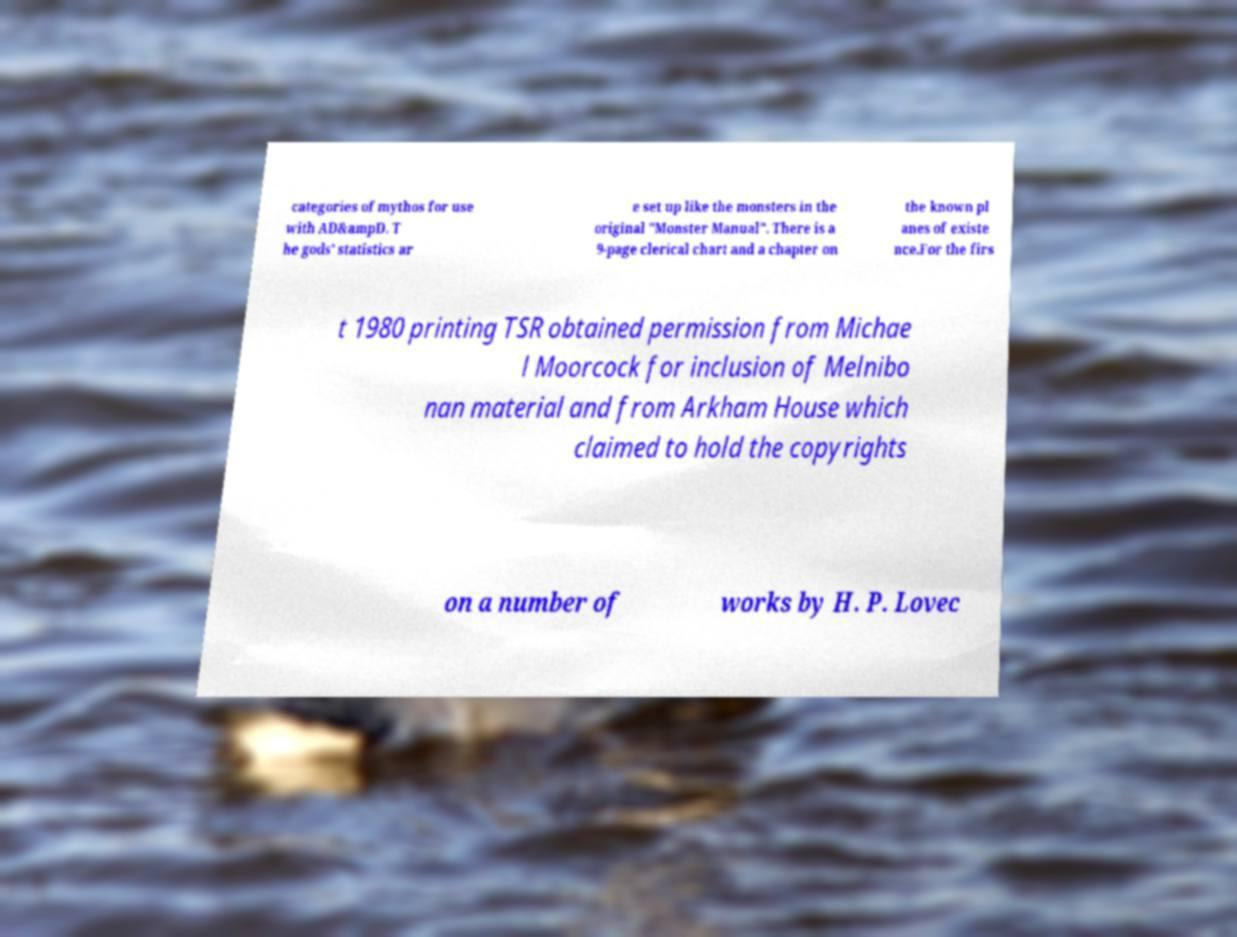I need the written content from this picture converted into text. Can you do that? categories of mythos for use with AD&ampD. T he gods' statistics ar e set up like the monsters in the original "Monster Manual". There is a 9-page clerical chart and a chapter on the known pl anes of existe nce.For the firs t 1980 printing TSR obtained permission from Michae l Moorcock for inclusion of Melnibo nan material and from Arkham House which claimed to hold the copyrights on a number of works by H. P. Lovec 